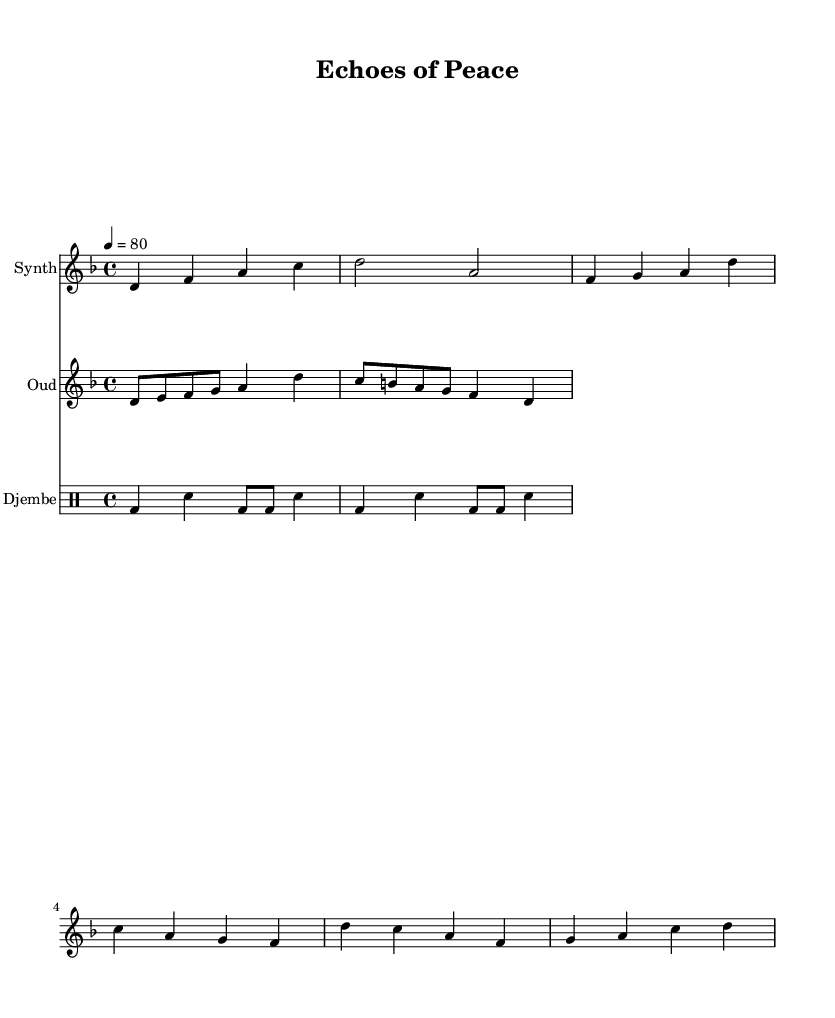What is the key signature of this music? The key signature is indicated at the beginning of the music staff, showing two flats. This reveals that the piece is in D minor.
Answer: D minor What is the time signature of this music? The time signature is displayed at the beginning of the piece, represented by the notation '4/4', which indicates four beats per measure.
Answer: 4/4 What is the tempo marking of the piece? The tempo marking is found at the start, showing '4 = 80'. This means there are 80 beats per minute, indicating a moderate pace.
Answer: 80 How many measures are in the synthesizer part? By counting the distinct measure lines within the synthesizer entry, there are a total of six measures present in the part.
Answer: Six Which traditional instrument is featured in this music? The traditional instrument is listed within the 'Staff' notation, where it is specified as "Oud", indicating its inclusion in the arrangement alongside the synthesizer.
Answer: Oud What is the rhythm pattern for the djembe? The rhythm pattern for the djembe is notated using the 'drummode', which details the sequence of notes. The pattern consists of a combination of bass and snare notes, forming a rhythmic motif across the measures.
Answer: Bass and snare pattern What is the first note played by the oud? The first note of the oud section is identified at the beginning of the part, which shows it starting with the note 'D', marking its entry in the measure.
Answer: D 